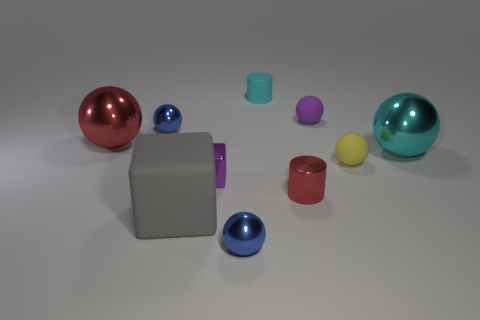Subtract all purple matte balls. How many balls are left? 5 Subtract all cyan balls. How many balls are left? 5 Subtract all brown balls. Subtract all purple cubes. How many balls are left? 6 Subtract all blocks. How many objects are left? 8 Add 2 small shiny blocks. How many small shiny blocks exist? 3 Subtract 0 green cubes. How many objects are left? 10 Subtract all large yellow cylinders. Subtract all small metallic cylinders. How many objects are left? 9 Add 5 tiny red metal objects. How many tiny red metal objects are left? 6 